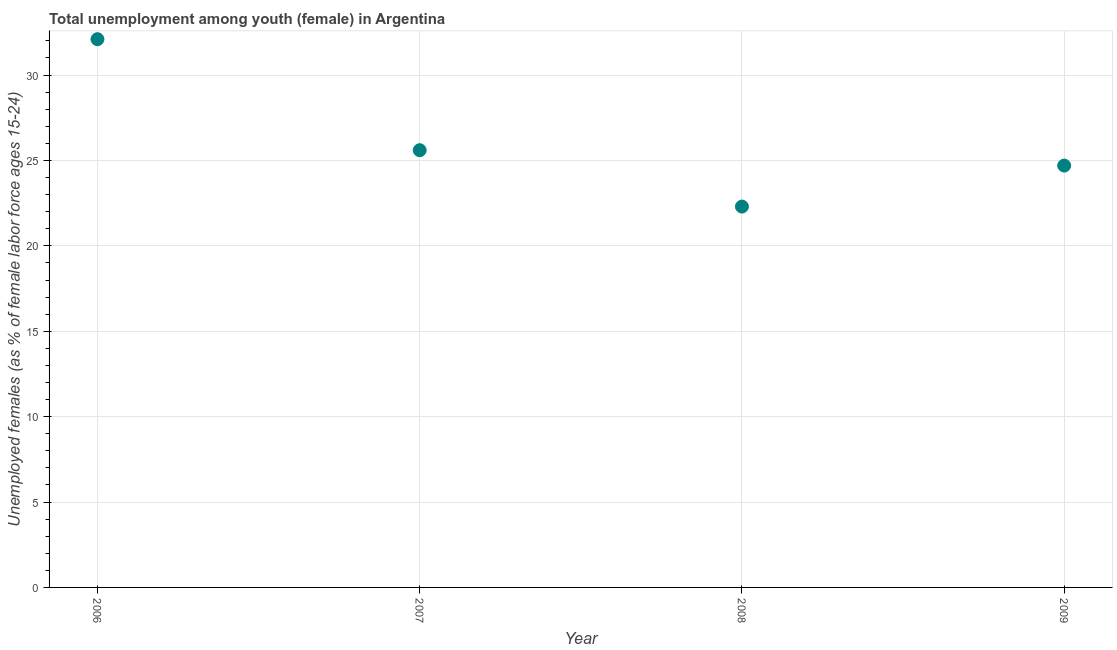What is the unemployed female youth population in 2006?
Keep it short and to the point. 32.1. Across all years, what is the maximum unemployed female youth population?
Your response must be concise. 32.1. Across all years, what is the minimum unemployed female youth population?
Provide a succinct answer. 22.3. In which year was the unemployed female youth population maximum?
Your response must be concise. 2006. What is the sum of the unemployed female youth population?
Keep it short and to the point. 104.7. What is the difference between the unemployed female youth population in 2006 and 2007?
Your response must be concise. 6.5. What is the average unemployed female youth population per year?
Keep it short and to the point. 26.17. What is the median unemployed female youth population?
Give a very brief answer. 25.15. What is the ratio of the unemployed female youth population in 2008 to that in 2009?
Provide a succinct answer. 0.9. What is the difference between the highest and the second highest unemployed female youth population?
Provide a succinct answer. 6.5. What is the difference between the highest and the lowest unemployed female youth population?
Give a very brief answer. 9.8. Does the unemployed female youth population monotonically increase over the years?
Offer a very short reply. No. How many dotlines are there?
Ensure brevity in your answer.  1. How many years are there in the graph?
Provide a succinct answer. 4. What is the title of the graph?
Your answer should be compact. Total unemployment among youth (female) in Argentina. What is the label or title of the X-axis?
Offer a very short reply. Year. What is the label or title of the Y-axis?
Offer a terse response. Unemployed females (as % of female labor force ages 15-24). What is the Unemployed females (as % of female labor force ages 15-24) in 2006?
Give a very brief answer. 32.1. What is the Unemployed females (as % of female labor force ages 15-24) in 2007?
Keep it short and to the point. 25.6. What is the Unemployed females (as % of female labor force ages 15-24) in 2008?
Keep it short and to the point. 22.3. What is the Unemployed females (as % of female labor force ages 15-24) in 2009?
Keep it short and to the point. 24.7. What is the difference between the Unemployed females (as % of female labor force ages 15-24) in 2006 and 2009?
Provide a succinct answer. 7.4. What is the difference between the Unemployed females (as % of female labor force ages 15-24) in 2007 and 2008?
Give a very brief answer. 3.3. What is the difference between the Unemployed females (as % of female labor force ages 15-24) in 2007 and 2009?
Offer a terse response. 0.9. What is the difference between the Unemployed females (as % of female labor force ages 15-24) in 2008 and 2009?
Ensure brevity in your answer.  -2.4. What is the ratio of the Unemployed females (as % of female labor force ages 15-24) in 2006 to that in 2007?
Provide a succinct answer. 1.25. What is the ratio of the Unemployed females (as % of female labor force ages 15-24) in 2006 to that in 2008?
Your answer should be very brief. 1.44. What is the ratio of the Unemployed females (as % of female labor force ages 15-24) in 2006 to that in 2009?
Your response must be concise. 1.3. What is the ratio of the Unemployed females (as % of female labor force ages 15-24) in 2007 to that in 2008?
Give a very brief answer. 1.15. What is the ratio of the Unemployed females (as % of female labor force ages 15-24) in 2007 to that in 2009?
Give a very brief answer. 1.04. What is the ratio of the Unemployed females (as % of female labor force ages 15-24) in 2008 to that in 2009?
Offer a very short reply. 0.9. 